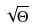<formula> <loc_0><loc_0><loc_500><loc_500>\sqrt { \Theta }</formula> 